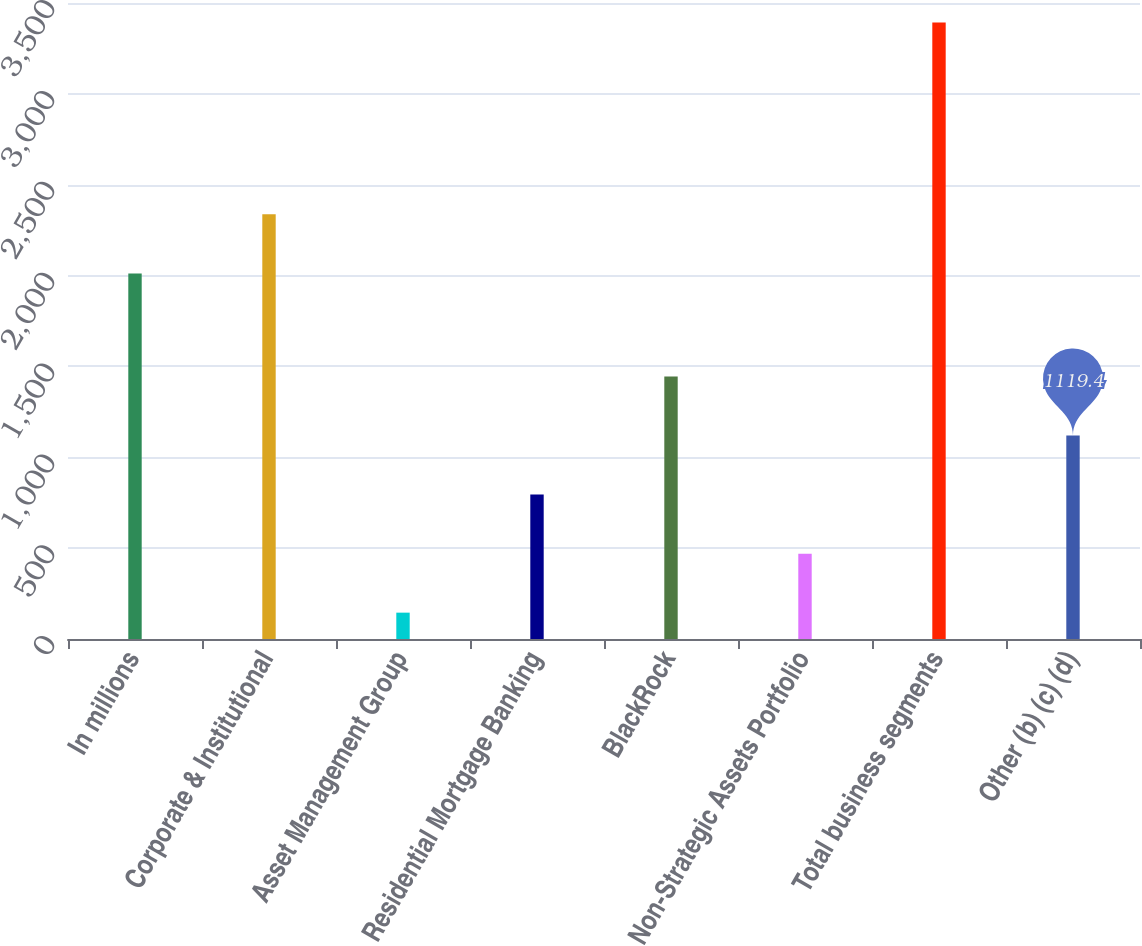Convert chart to OTSL. <chart><loc_0><loc_0><loc_500><loc_500><bar_chart><fcel>In millions<fcel>Corporate & Institutional<fcel>Asset Management Group<fcel>Residential Mortgage Banking<fcel>BlackRock<fcel>Non-Strategic Assets Portfolio<fcel>Total business segments<fcel>Other (b) (c) (d)<nl><fcel>2012<fcel>2336.8<fcel>145<fcel>794.6<fcel>1444.2<fcel>469.8<fcel>3393<fcel>1119.4<nl></chart> 